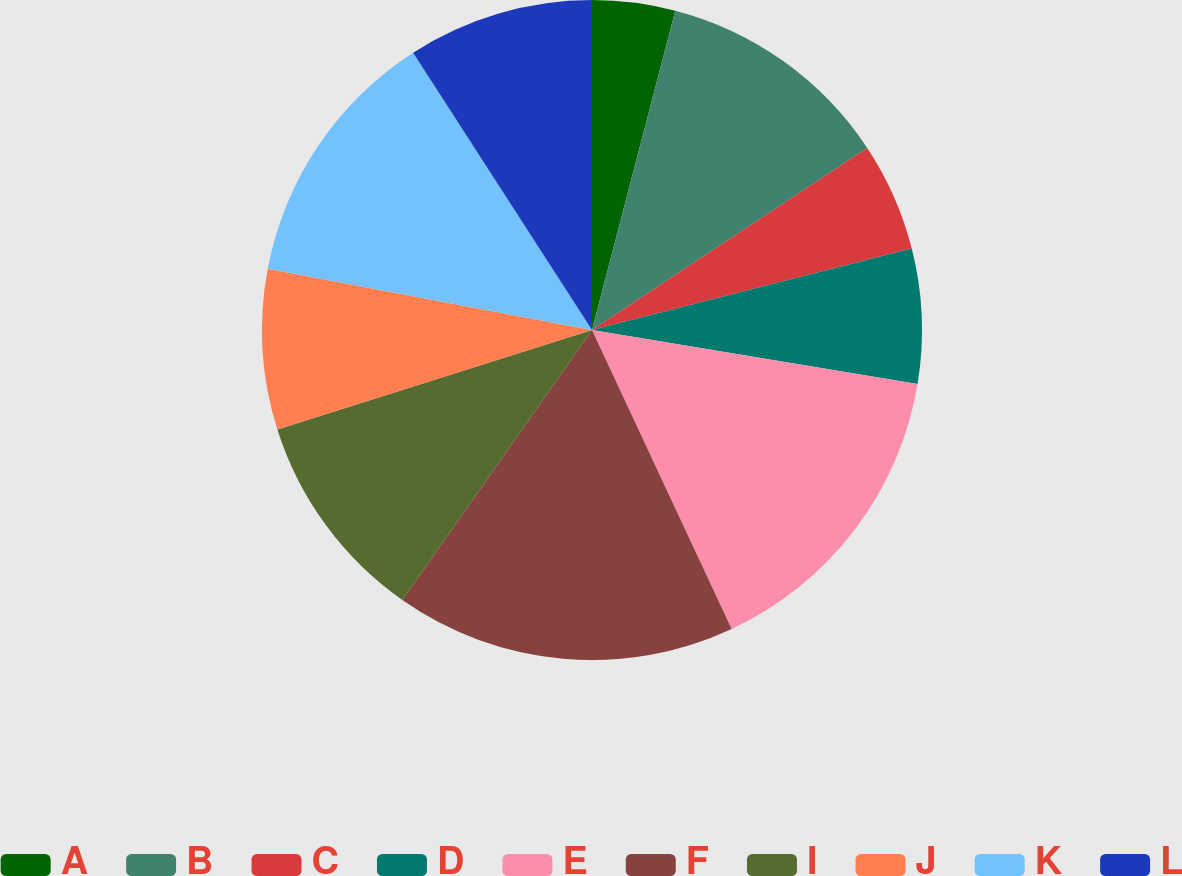<chart> <loc_0><loc_0><loc_500><loc_500><pie_chart><fcel>A<fcel>B<fcel>C<fcel>D<fcel>E<fcel>F<fcel>I<fcel>J<fcel>K<fcel>L<nl><fcel>4.06%<fcel>11.64%<fcel>5.33%<fcel>6.59%<fcel>15.43%<fcel>16.7%<fcel>10.38%<fcel>7.85%<fcel>12.91%<fcel>9.12%<nl></chart> 